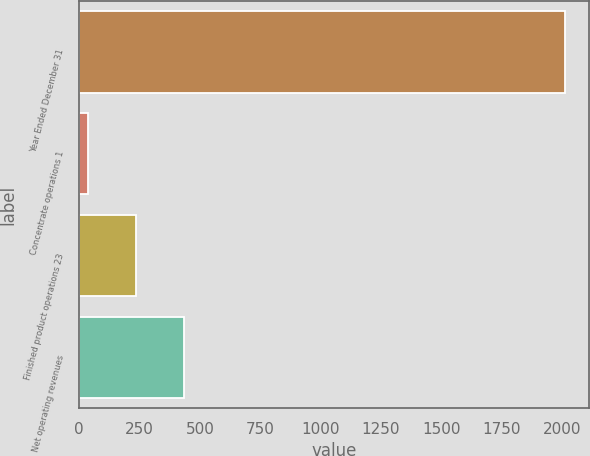<chart> <loc_0><loc_0><loc_500><loc_500><bar_chart><fcel>Year Ended December 31<fcel>Concentrate operations 1<fcel>Finished product operations 23<fcel>Net operating revenues<nl><fcel>2011<fcel>39<fcel>236.2<fcel>433.4<nl></chart> 